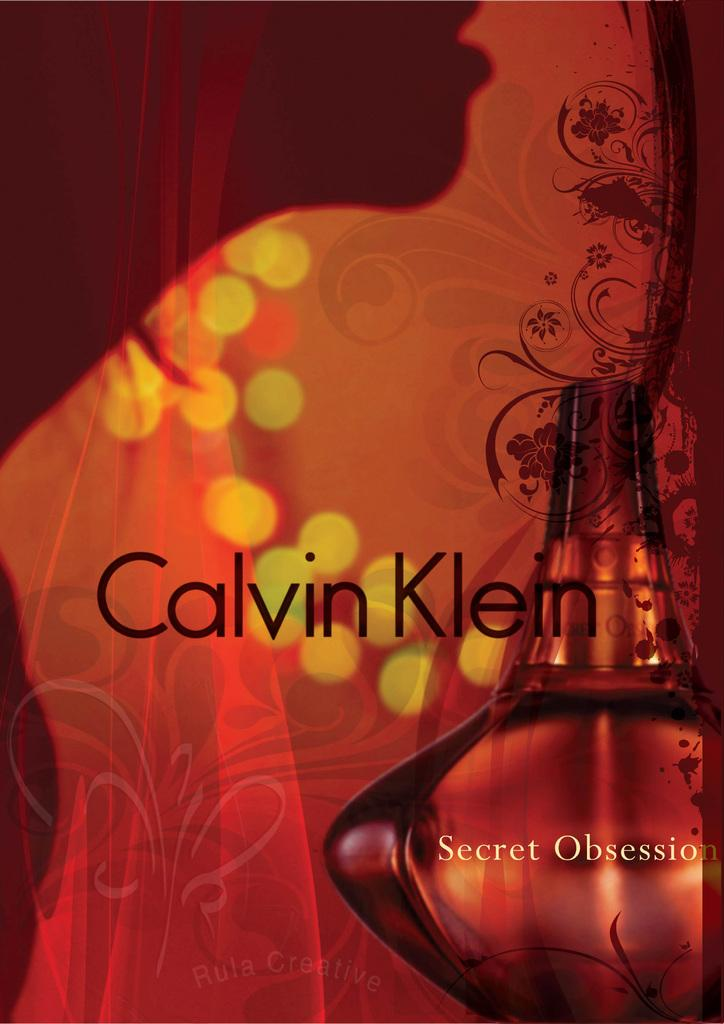<image>
Render a clear and concise summary of the photo. A bottle of perfume from Calvin Klein with a shadow of a woman at the background. 